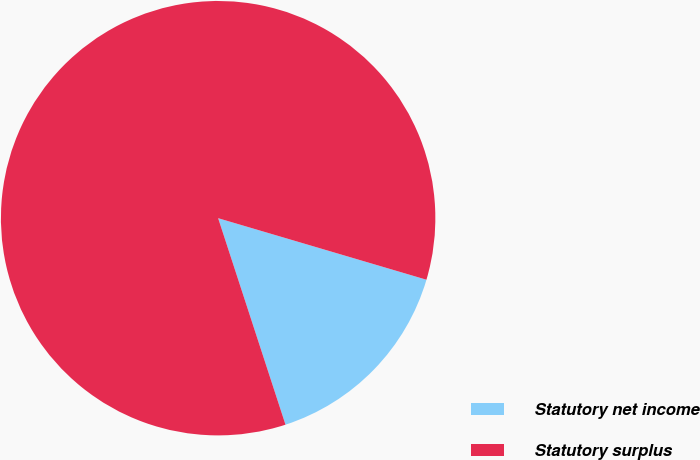Convert chart. <chart><loc_0><loc_0><loc_500><loc_500><pie_chart><fcel>Statutory net income<fcel>Statutory surplus<nl><fcel>15.41%<fcel>84.59%<nl></chart> 